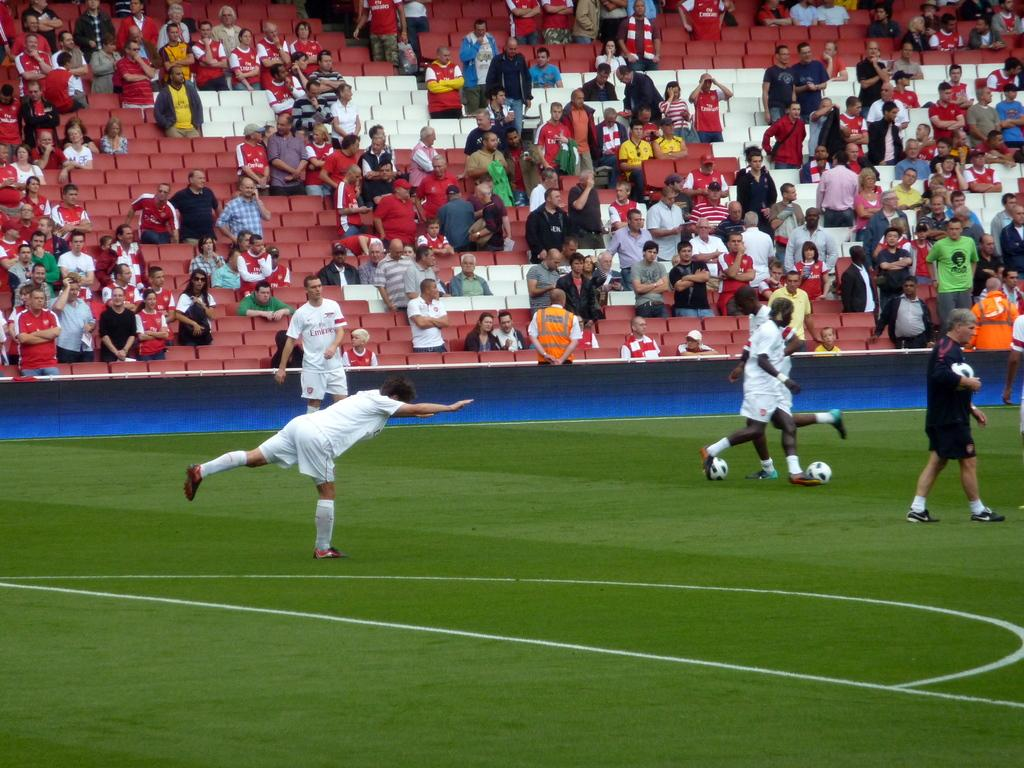<image>
Share a concise interpretation of the image provided. A group of people playing soccer one has a lumineer jersey. 